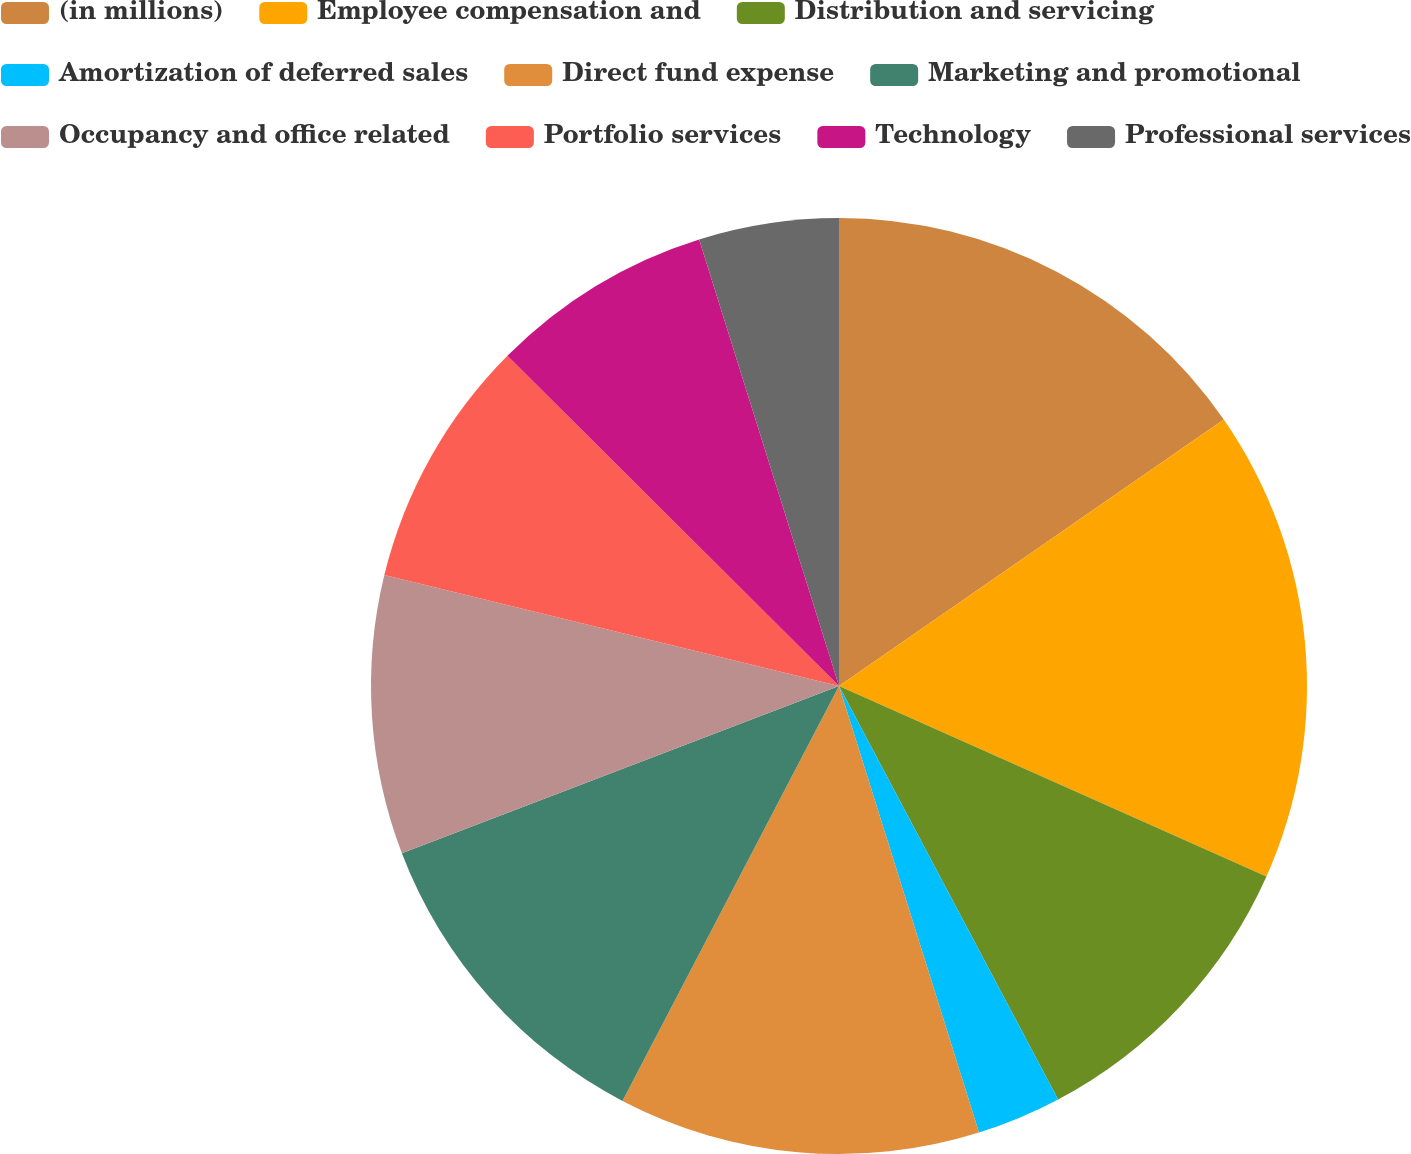<chart> <loc_0><loc_0><loc_500><loc_500><pie_chart><fcel>(in millions)<fcel>Employee compensation and<fcel>Distribution and servicing<fcel>Amortization of deferred sales<fcel>Direct fund expense<fcel>Marketing and promotional<fcel>Occupancy and office related<fcel>Portfolio services<fcel>Technology<fcel>Professional services<nl><fcel>15.36%<fcel>16.31%<fcel>10.57%<fcel>2.92%<fcel>12.49%<fcel>11.53%<fcel>9.62%<fcel>8.66%<fcel>7.7%<fcel>4.83%<nl></chart> 